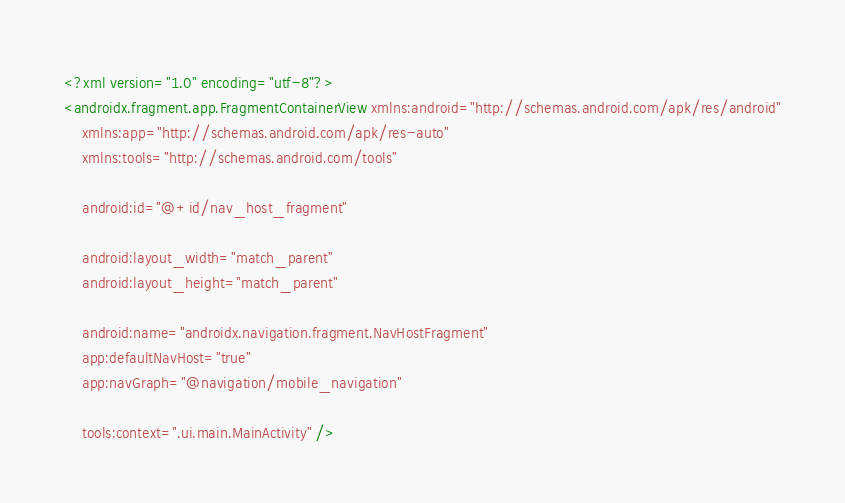<code> <loc_0><loc_0><loc_500><loc_500><_XML_><?xml version="1.0" encoding="utf-8"?>
<androidx.fragment.app.FragmentContainerView xmlns:android="http://schemas.android.com/apk/res/android"
    xmlns:app="http://schemas.android.com/apk/res-auto"
    xmlns:tools="http://schemas.android.com/tools"

    android:id="@+id/nav_host_fragment"

    android:layout_width="match_parent"
    android:layout_height="match_parent"

    android:name="androidx.navigation.fragment.NavHostFragment"
    app:defaultNavHost="true"
    app:navGraph="@navigation/mobile_navigation"

    tools:context=".ui.main.MainActivity" />
</code> 